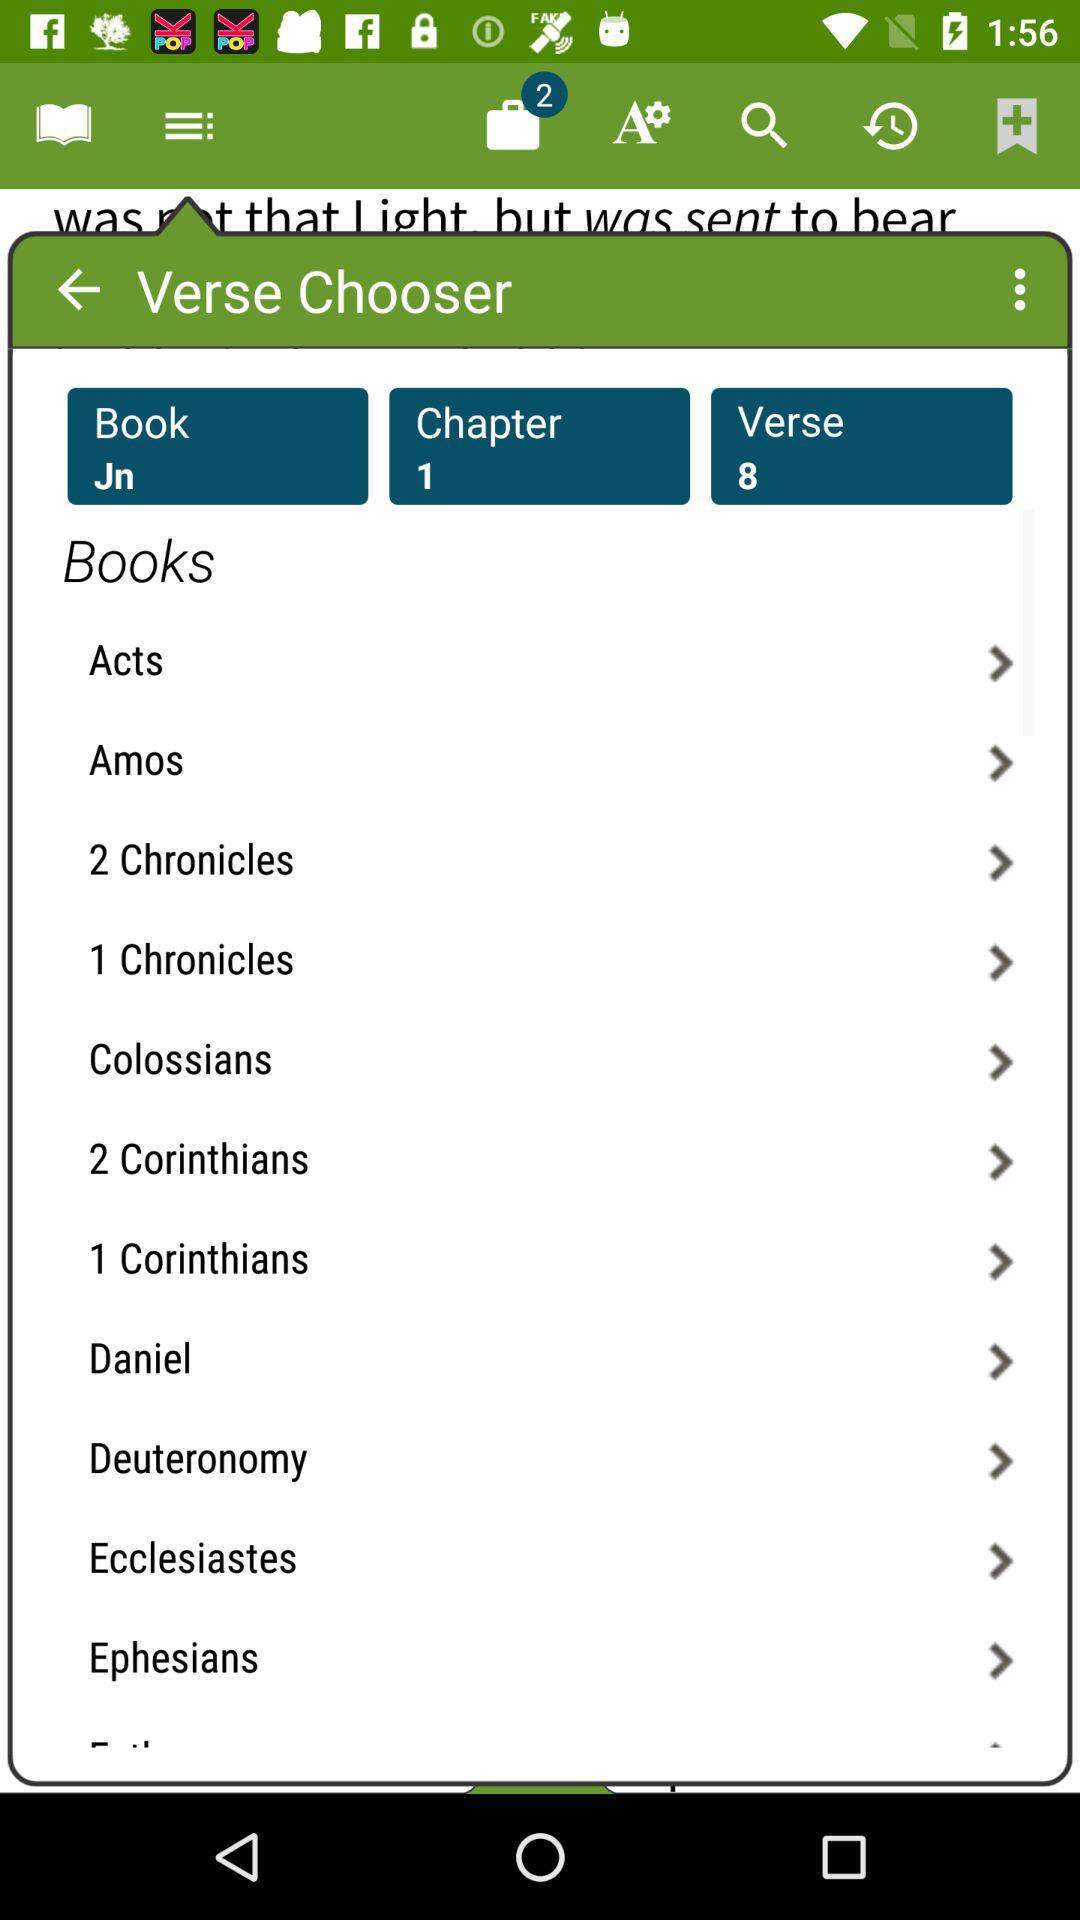Which verses have already been read?
When the provided information is insufficient, respond with <no answer>. <no answer> 